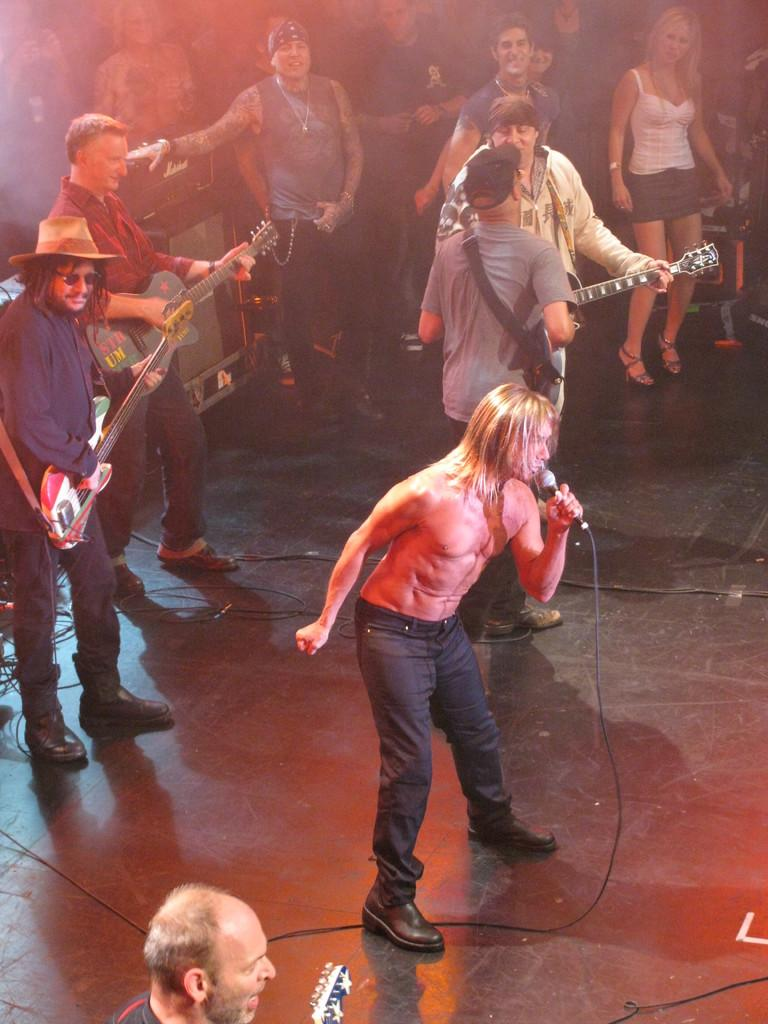How many people are in the image? There are multiple people in the image. What are some of the people holding? Some of the people are holding guitars. Can you describe the man in the image? There is a man holding a microphone. What type of hen can be seen walking on the sidewalk in the image? There is no hen or sidewalk present in the image; it features multiple people, some of whom are holding guitars and one holding a microphone. 